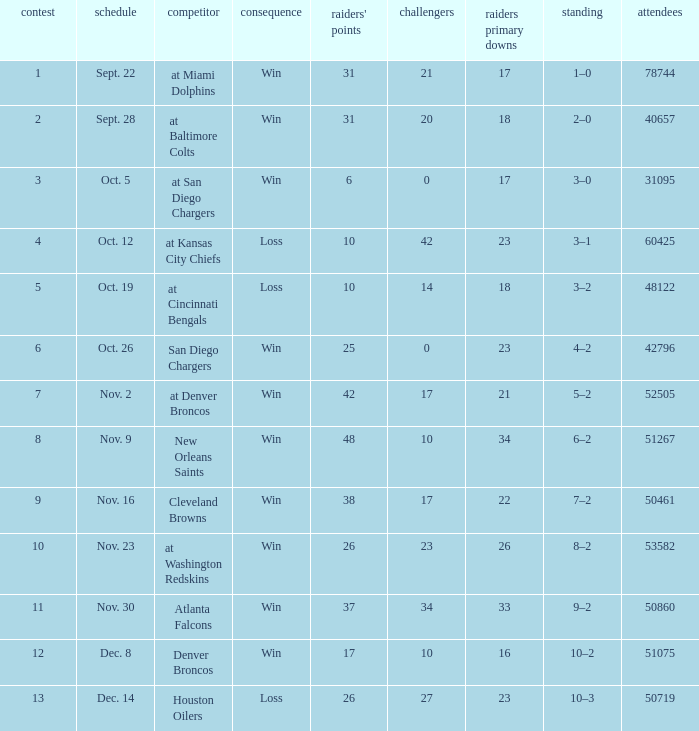What was the result of the game seen by 31095 people? Win. 